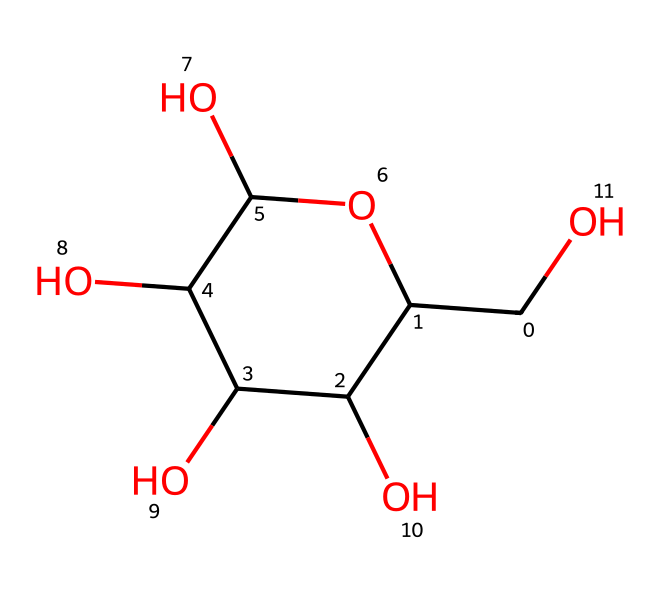What is the molecular formula of this starch? To determine the molecular formula, we need to count the number of carbon (C), hydrogen (H), and oxygen (O) atoms represented by the SMILES structure. The count reveals 6 carbon atoms, 12 hydrogen atoms, and 6 oxygen atoms, leading to the formula C6H12O6.
Answer: C6H12O6 How many hydroxyl (OH) groups are present in the structure? The hydroxyl groups (OH) can be identified by observing the oxygen atoms bonded to hydrogen in the structure. There are five instances where carbon atoms are bonded to an oxygen atom and a hydrogen atom together, indicating the presence of five hydroxyl groups.
Answer: 5 What type of carbohydrate is represented by this structure? This structure corresponds to a polysaccharide, as starch is a complex carbohydrate composed of multiple monosaccharide units (glucose). Therefore, the carbohydrate type represented here is a polysaccharide.
Answer: polysaccharide What is the role of the alpha-glucosidic bonds in starch? The structural representation allows us to infer that the bonds connecting the glucose units are alpha-glucosidic bonds. These bonds are crucial for the storage function of starch as they allow branching and provide energy storage in plants.
Answer: energy storage How many cyclic structures are visible in this starch representation? In the chemical structure, the presence of a cyclic character can be seen in one of the glucose units depicted in the SMILES representation. The cyclic structure indicates that starch includes at least one glucose unit in its ring form. Therefore, there is one cyclic structure present.
Answer: 1 